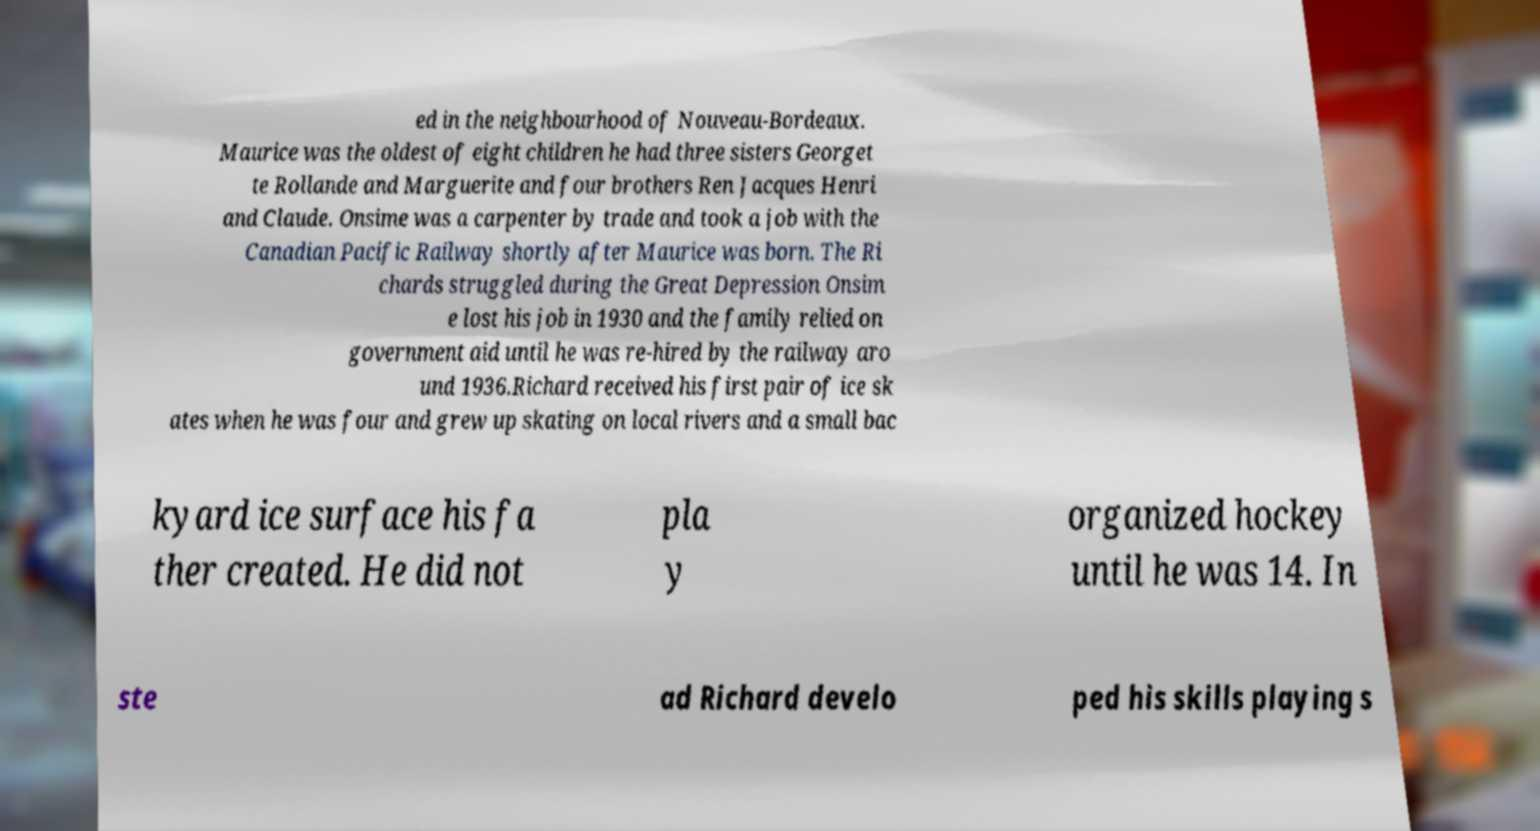Could you assist in decoding the text presented in this image and type it out clearly? ed in the neighbourhood of Nouveau-Bordeaux. Maurice was the oldest of eight children he had three sisters Georget te Rollande and Marguerite and four brothers Ren Jacques Henri and Claude. Onsime was a carpenter by trade and took a job with the Canadian Pacific Railway shortly after Maurice was born. The Ri chards struggled during the Great Depression Onsim e lost his job in 1930 and the family relied on government aid until he was re-hired by the railway aro und 1936.Richard received his first pair of ice sk ates when he was four and grew up skating on local rivers and a small bac kyard ice surface his fa ther created. He did not pla y organized hockey until he was 14. In ste ad Richard develo ped his skills playing s 